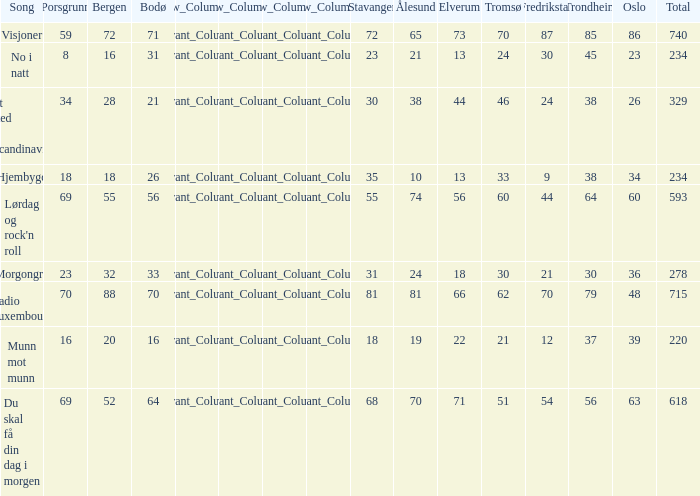What is the lowest total? 220.0. 